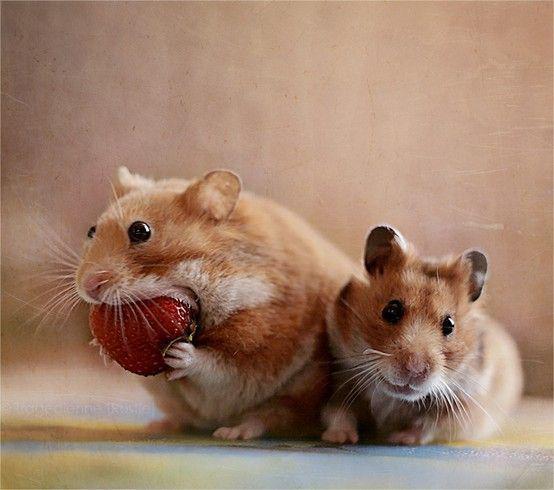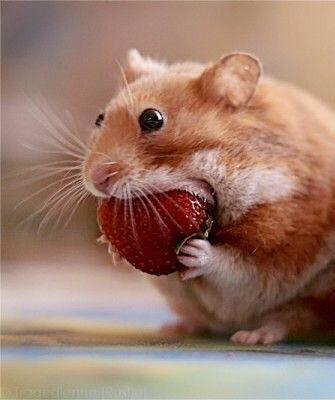The first image is the image on the left, the second image is the image on the right. Considering the images on both sides, is "Each image shows a hamster that is eating." valid? Answer yes or no. Yes. 